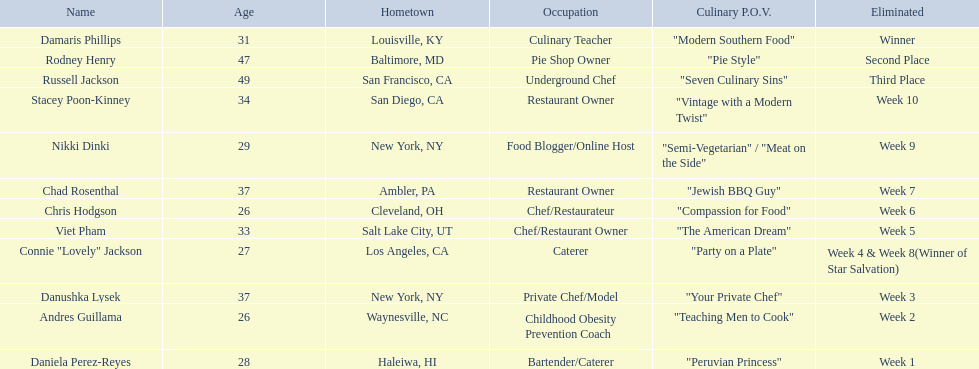Who are all of the people listed? Damaris Phillips, Rodney Henry, Russell Jackson, Stacey Poon-Kinney, Nikki Dinki, Chad Rosenthal, Chris Hodgson, Viet Pham, Connie "Lovely" Jackson, Danushka Lysek, Andres Guillama, Daniela Perez-Reyes. How old are they? 31, 47, 49, 34, 29, 37, 26, 33, 27, 37, 26, 28. Along with chris hodgson, which other person is 26 years old? Andres Guillama. 